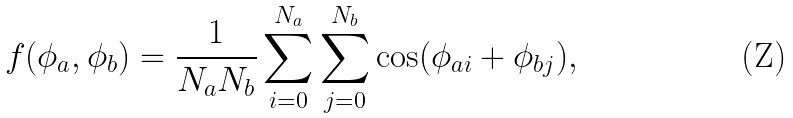<formula> <loc_0><loc_0><loc_500><loc_500>f ( \phi _ { a } , \phi _ { b } ) = \frac { 1 } { N _ { a } N _ { b } } \sum _ { i = 0 } ^ { N _ { a } } \sum _ { j = 0 } ^ { N _ { b } } \cos ( \phi _ { a i } + \phi _ { b j } ) ,</formula> 